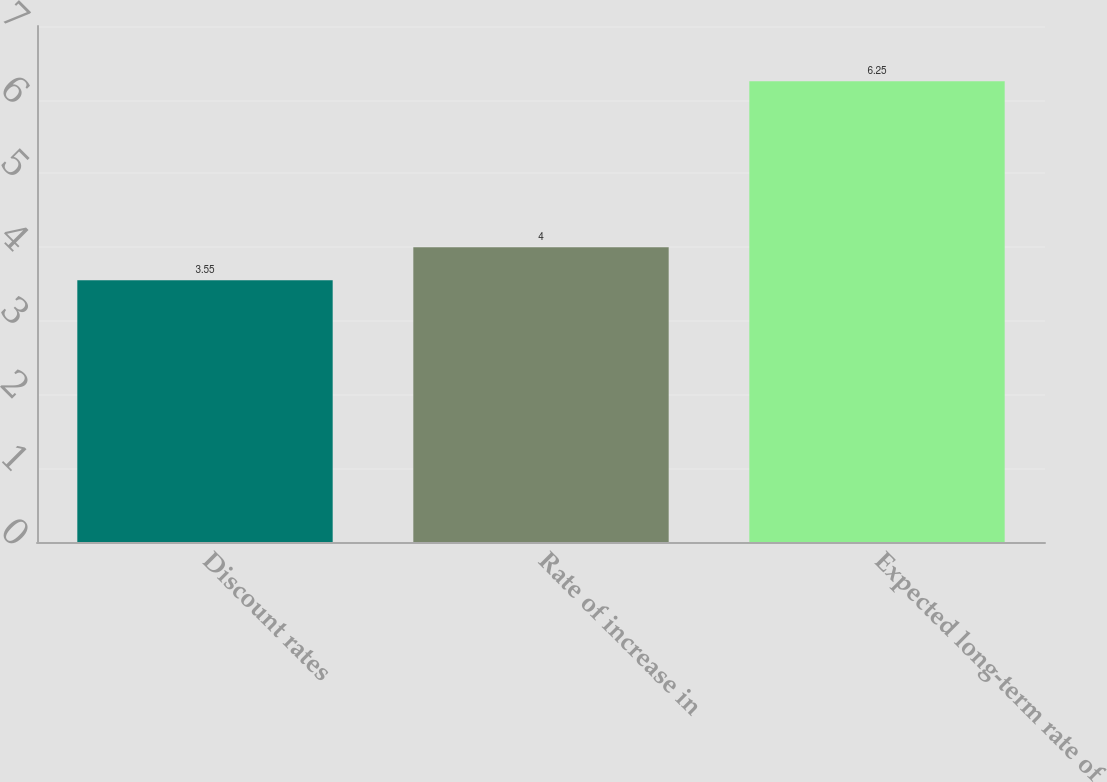Convert chart. <chart><loc_0><loc_0><loc_500><loc_500><bar_chart><fcel>Discount rates<fcel>Rate of increase in<fcel>Expected long-term rate of<nl><fcel>3.55<fcel>4<fcel>6.25<nl></chart> 